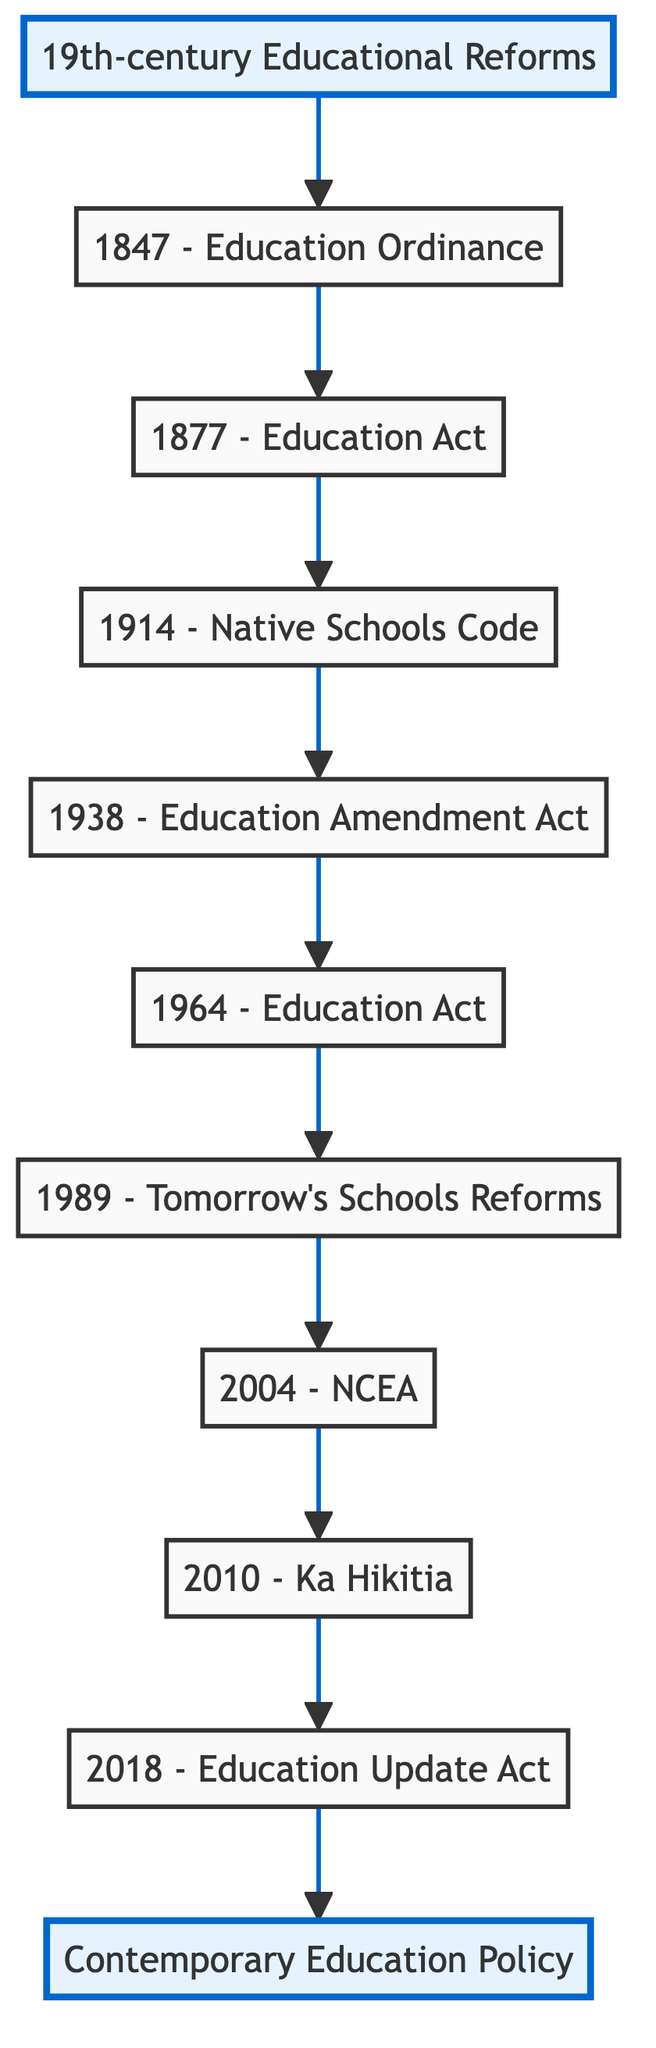What is the top node in the flow chart? The top node is "Contemporary Education Policy," which represents the current state of New Zealand's education policies.
Answer: Contemporary Education Policy How many elements are there in the flow chart? Counting each node from the bottom to the top, there are 10 elements in total: one bottom node, eight intermediate nodes, and one top node.
Answer: 10 Which educational reform introduced free, compulsory, and secular education? This reform is the "1877 - Education Act," which was pivotal in making education accessible to all children in New Zealand.
Answer: 1877 - Education Act What year did the "Tomorrow's Schools Reforms" occur? The "Tomorrow's Schools Reforms" took place in the year 1989, marking a significant shift in school administration in New Zealand.
Answer: 1989 Which node comes directly after the "1914 - Native Schools Code"? The node that follows directly is the "1938 - Education Amendment Act," which prioritized secondary education.
Answer: 1938 - Education Amendment Act What does the "2004 - NCEA" node signify in the flow chart? The "2004 - NCEA" node indicates the introduction of a standards-based assessment system that replaced the previous examination-based approach in secondary schools.
Answer: National Certificate of Educational Achievement (NCEA) Which legislation emphasized improving educational outcomes for Māori learners? The relevant initiative is "2010 - Ka Hikitia – Managing for Success," which was a strategic plan focused on Māori students' educational success.
Answer: Ka Hikitia – Managing for Success Between which two nodes is the "1964 - Education Act" located? The "1964 - Education Act" is positioned between the "1938 - Education Amendment Act" and the "1989 - Tomorrow's Schools Reforms" in the flow.
Answer: 1938 - Education Amendment Act and 1989 - Tomorrow's Schools Reforms What type of educational approaches does the "2018 - Education (Update) Amendment Act" node address? This node addresses modern educational needs including digital literacy and inclusive education, reflecting changes in contemporary teaching requirements.
Answer: Digital literacy and inclusive education 